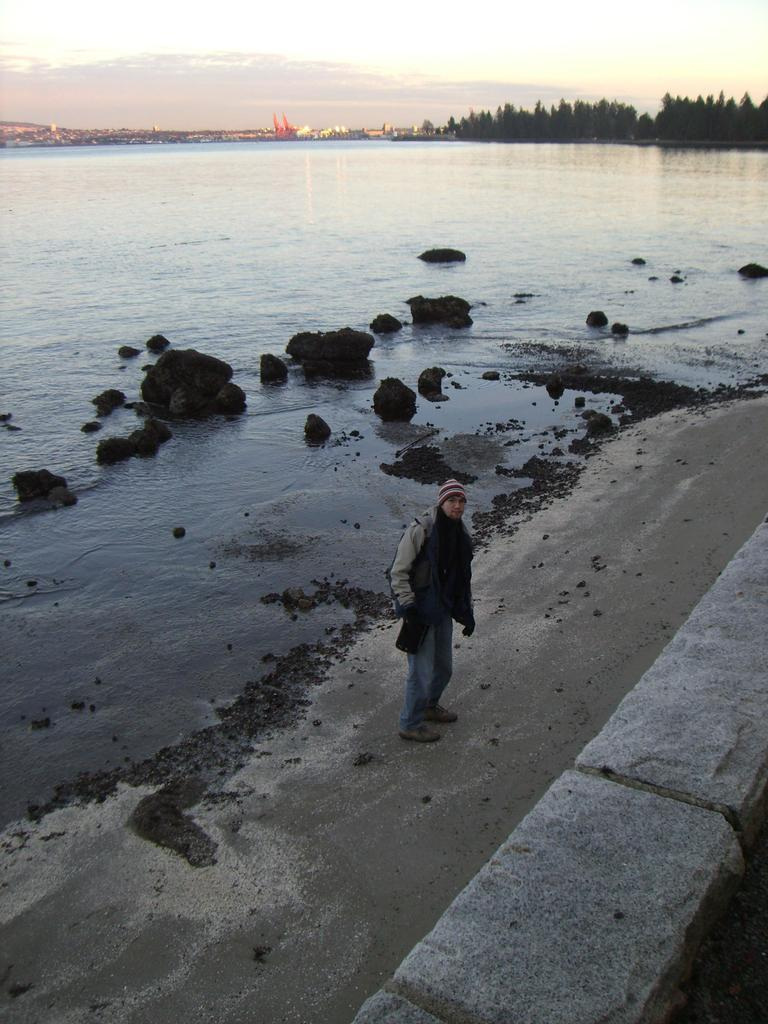Who is the main subject in the image? There is a man in the middle of the image. What is the man wearing on his head? The man is wearing a cap. What type of natural features can be seen behind the man? There are rocks and water visible behind the man. What other elements can be seen in the background of the image? There are trees and clouds in the background of the image. How many trains can be seen in the image? There are no trains present in the image. Is the man sleeping in the image? The image does not show the man sleeping; he is standing and wearing a cap. 